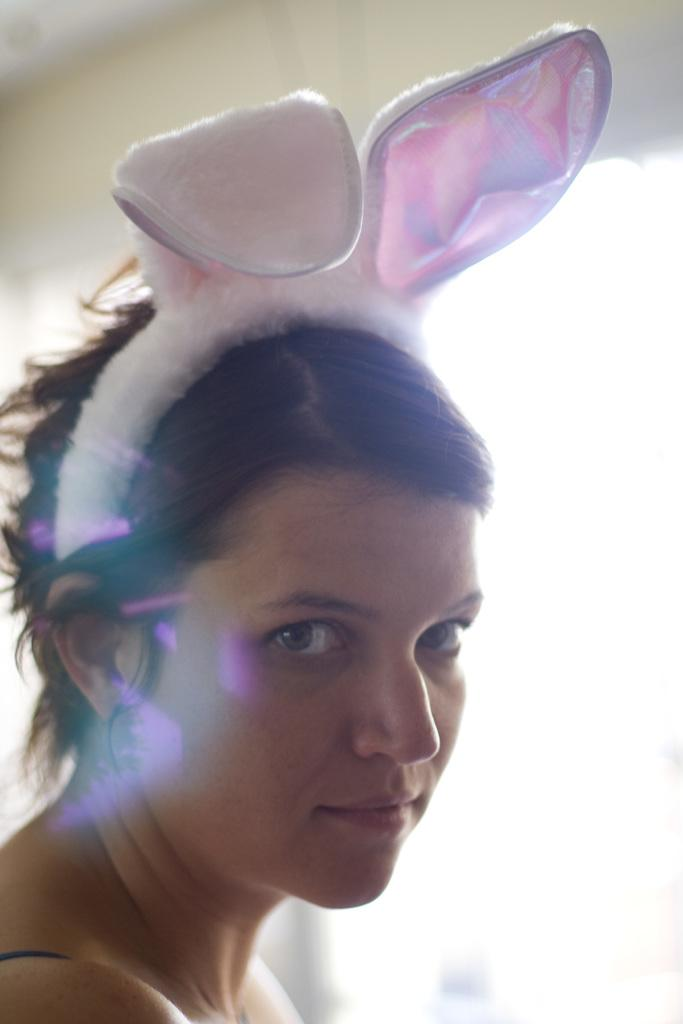Who is the main subject in the image? There is a woman in the picture. What is the woman wearing on her head? The woman is wearing a rabbit headband. Can you describe the background of the image? The background of the image is blurred. What type of shoes is the woman wearing in the image? The provided facts do not mention any shoes, so we cannot determine the type of shoes the woman is wearing in the image. 